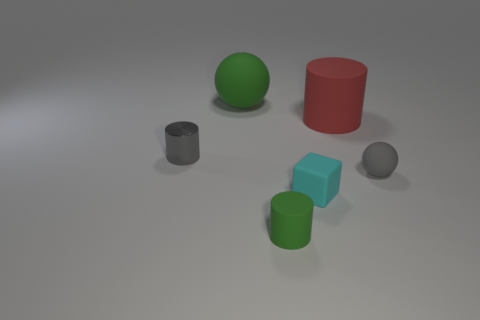How big is the green ball?
Your answer should be very brief. Large. What is the shape of the cyan thing?
Your answer should be very brief. Cube. Is there any other thing that is the same shape as the small cyan rubber thing?
Your response must be concise. No. Are there fewer large green objects to the right of the big green ball than rubber blocks?
Keep it short and to the point. Yes. Does the matte cylinder behind the tiny matte cube have the same color as the block?
Your answer should be compact. No. How many metal things are blocks or big blue blocks?
Give a very brief answer. 0. What color is the tiny sphere that is the same material as the large green ball?
Provide a succinct answer. Gray. What number of cylinders are either shiny objects or big red rubber things?
Provide a short and direct response. 2. What number of objects are small purple matte blocks or matte objects that are behind the gray cylinder?
Offer a very short reply. 2. Is there a big purple block?
Keep it short and to the point. No. 